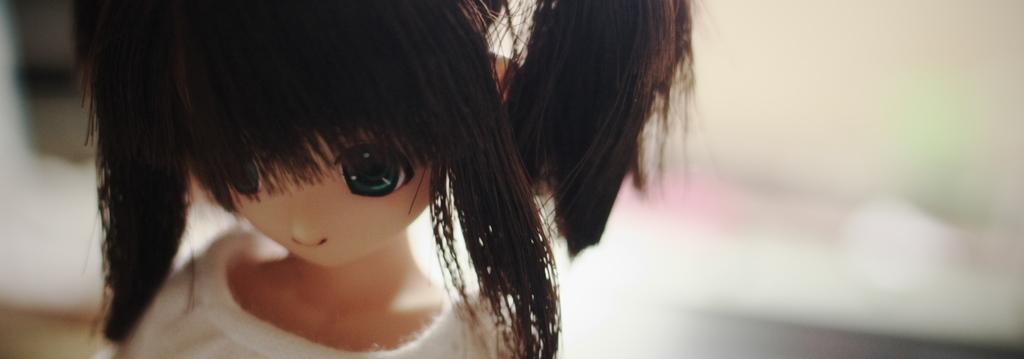What is the main subject of the image? There is a doll in the image. What colors can be seen on the doll? The doll is cream and black in color. What is the doll wearing? The doll is wearing a white dress. How would you describe the background of the image? The background of the image is blurry. What type of tramp can be seen in the background of the image? There is no tramp present in the image; the background is blurry. What shape is the truck in the image? There is no truck present in the image. 